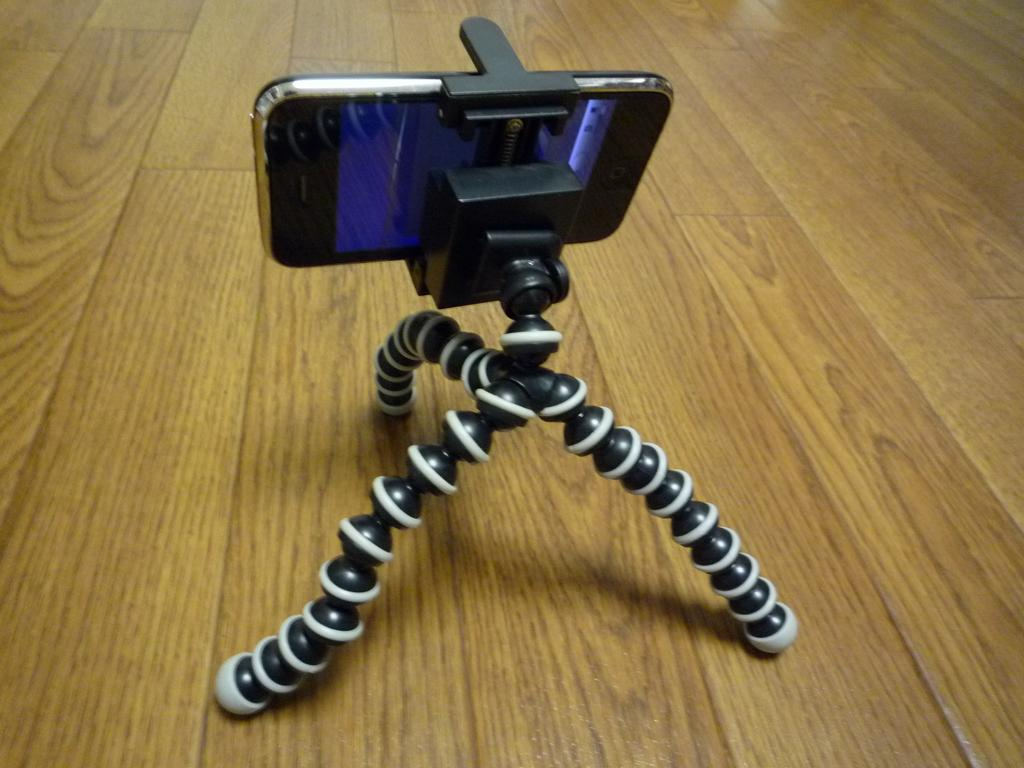What is the main object in the image? There is a camera stand in the image. Where is the camera stand located? The camera stand is on the floor. What other electronic device is present in the image? There is a mobile phone in the image. Can you see a boot on the camera stand in the image? There is no boot present on the camera stand in the image. Is there a giraffe visible in the image? There is no giraffe present in the image. 